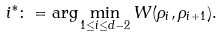Convert formula to latex. <formula><loc_0><loc_0><loc_500><loc_500>i ^ { * } \colon = \arg \min _ { 1 \leq i \leq d - 2 } W ( \rho _ { i } , \rho _ { i + 1 } ) .</formula> 